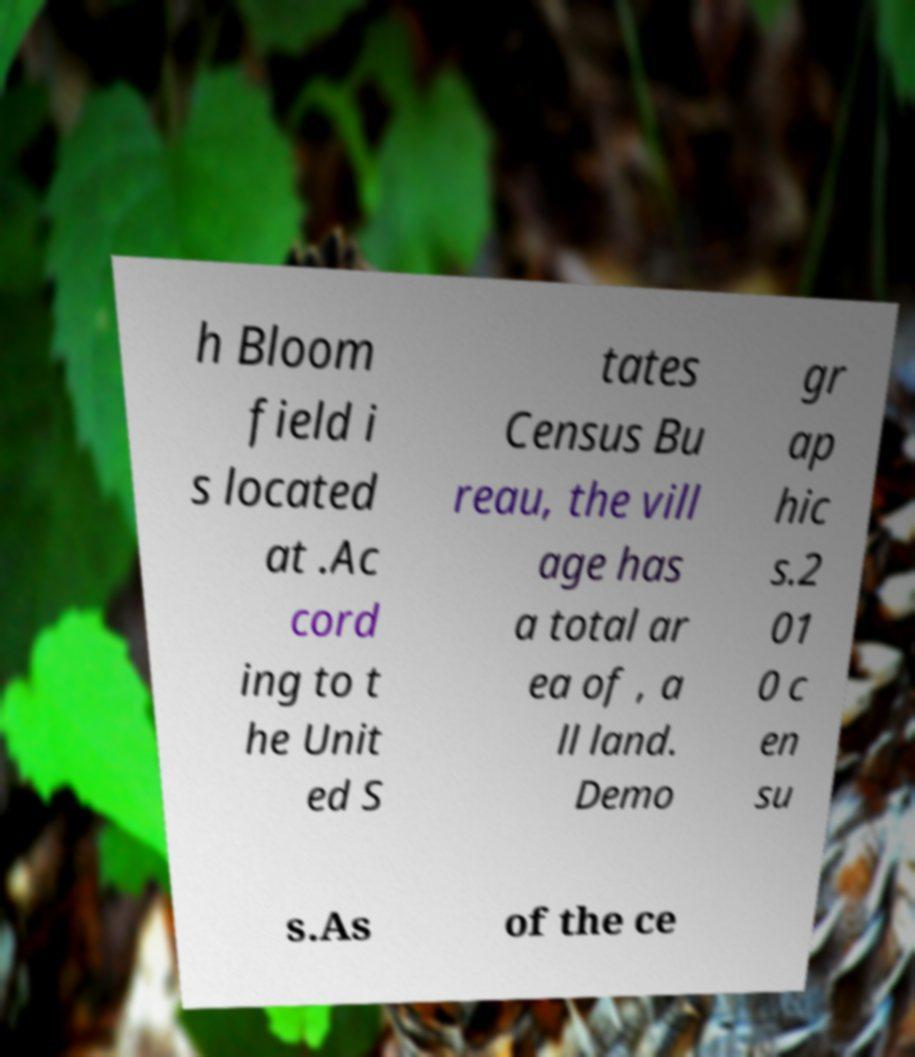There's text embedded in this image that I need extracted. Can you transcribe it verbatim? h Bloom field i s located at .Ac cord ing to t he Unit ed S tates Census Bu reau, the vill age has a total ar ea of , a ll land. Demo gr ap hic s.2 01 0 c en su s.As of the ce 